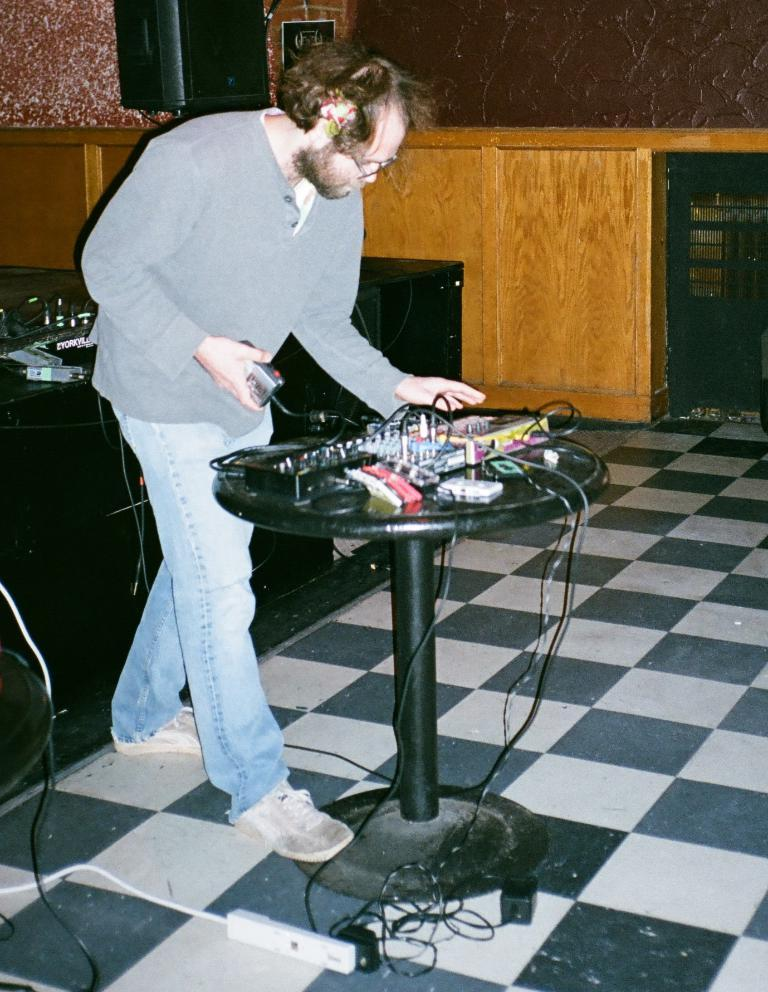What is the person in the image doing? The person is operating a sound system. Where is the person standing in relation to the table? The person is standing in front of a table. What can be found on the table? There are spare parts on the table. Can you describe the speaker in the image? There is a speaker mounted on the wall. How many deer are visible in the image? There are no deer present in the image. What type of wheel is being used by the person in the image? The person in the image is not using any wheel; they are operating a sound system. 